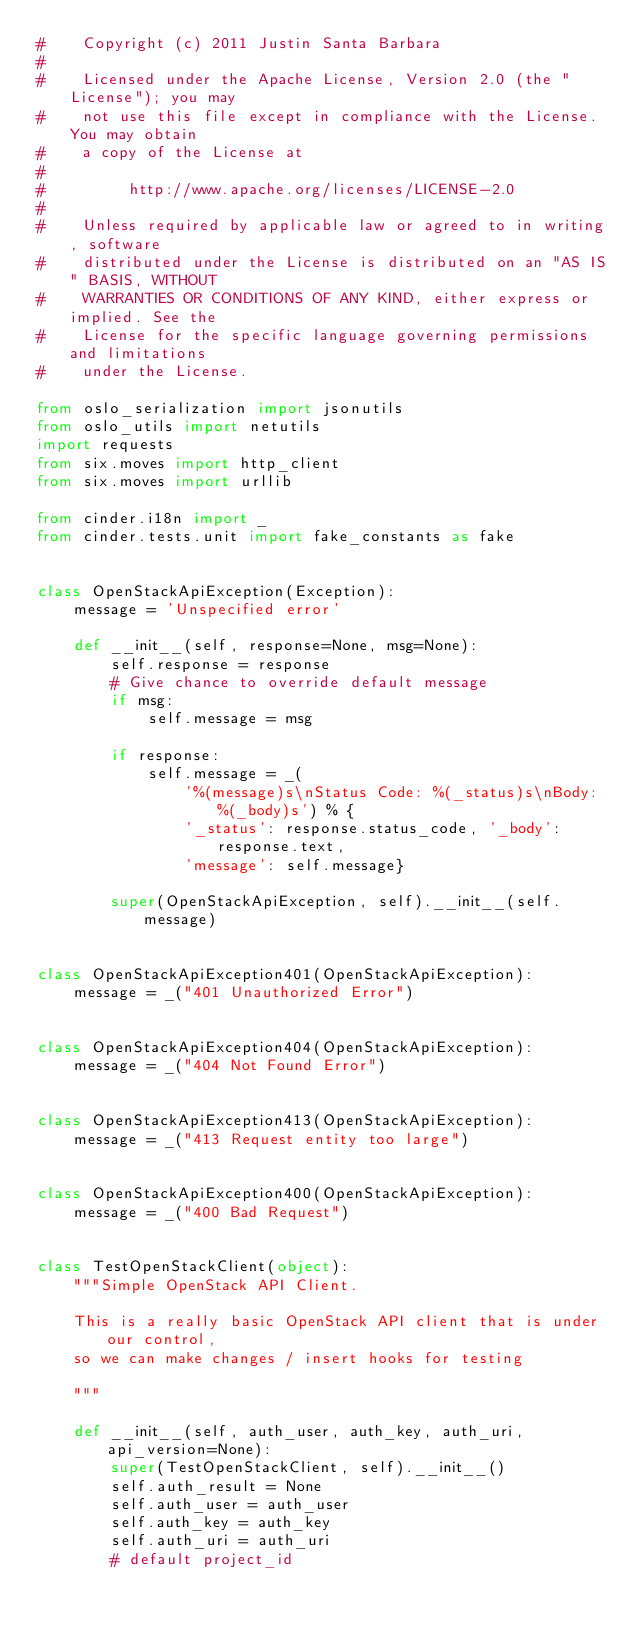<code> <loc_0><loc_0><loc_500><loc_500><_Python_>#    Copyright (c) 2011 Justin Santa Barbara
#
#    Licensed under the Apache License, Version 2.0 (the "License"); you may
#    not use this file except in compliance with the License. You may obtain
#    a copy of the License at
#
#         http://www.apache.org/licenses/LICENSE-2.0
#
#    Unless required by applicable law or agreed to in writing, software
#    distributed under the License is distributed on an "AS IS" BASIS, WITHOUT
#    WARRANTIES OR CONDITIONS OF ANY KIND, either express or implied. See the
#    License for the specific language governing permissions and limitations
#    under the License.

from oslo_serialization import jsonutils
from oslo_utils import netutils
import requests
from six.moves import http_client
from six.moves import urllib

from cinder.i18n import _
from cinder.tests.unit import fake_constants as fake


class OpenStackApiException(Exception):
    message = 'Unspecified error'

    def __init__(self, response=None, msg=None):
        self.response = response
        # Give chance to override default message
        if msg:
            self.message = msg

        if response:
            self.message = _(
                '%(message)s\nStatus Code: %(_status)s\nBody: %(_body)s') % {
                '_status': response.status_code, '_body': response.text,
                'message': self.message}

        super(OpenStackApiException, self).__init__(self.message)


class OpenStackApiException401(OpenStackApiException):
    message = _("401 Unauthorized Error")


class OpenStackApiException404(OpenStackApiException):
    message = _("404 Not Found Error")


class OpenStackApiException413(OpenStackApiException):
    message = _("413 Request entity too large")


class OpenStackApiException400(OpenStackApiException):
    message = _("400 Bad Request")


class TestOpenStackClient(object):
    """Simple OpenStack API Client.

    This is a really basic OpenStack API client that is under our control,
    so we can make changes / insert hooks for testing

    """

    def __init__(self, auth_user, auth_key, auth_uri, api_version=None):
        super(TestOpenStackClient, self).__init__()
        self.auth_result = None
        self.auth_user = auth_user
        self.auth_key = auth_key
        self.auth_uri = auth_uri
        # default project_id</code> 